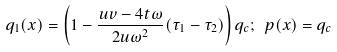<formula> <loc_0><loc_0><loc_500><loc_500>q _ { 1 } ( x ) = \left ( 1 - \frac { u v - 4 t \omega } { 2 u \omega ^ { 2 } } ( \tau _ { 1 } - \tau _ { 2 } ) \right ) q _ { c } ; \ p ( x ) = q _ { c }</formula> 